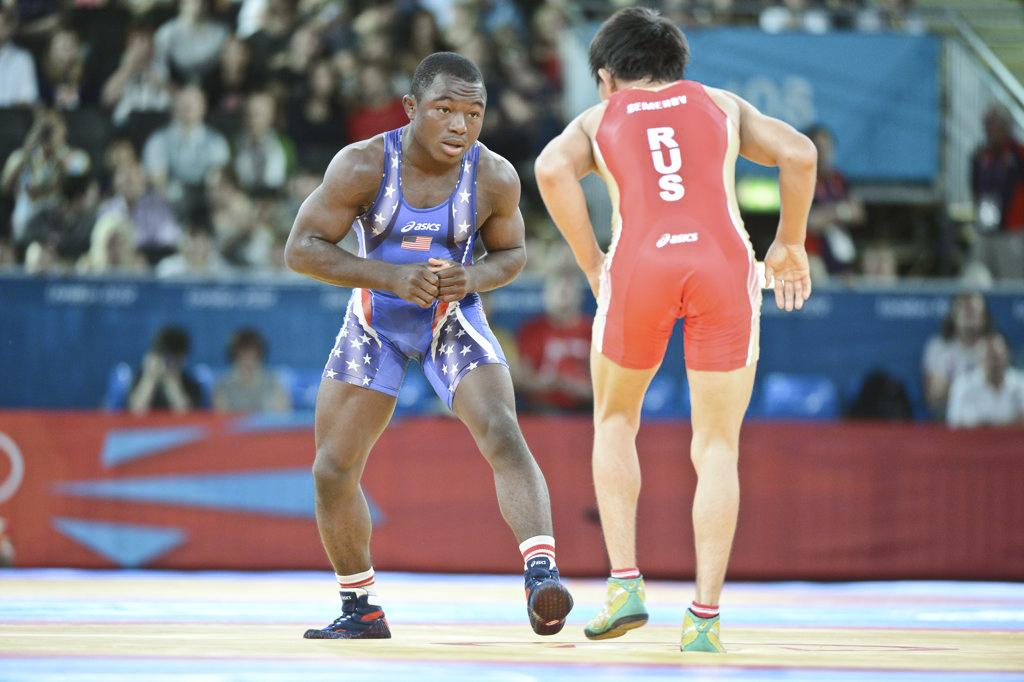Provide a one-sentence caption for the provided image. A wrestler competes as his singlet proclaims his Russian heritage. 